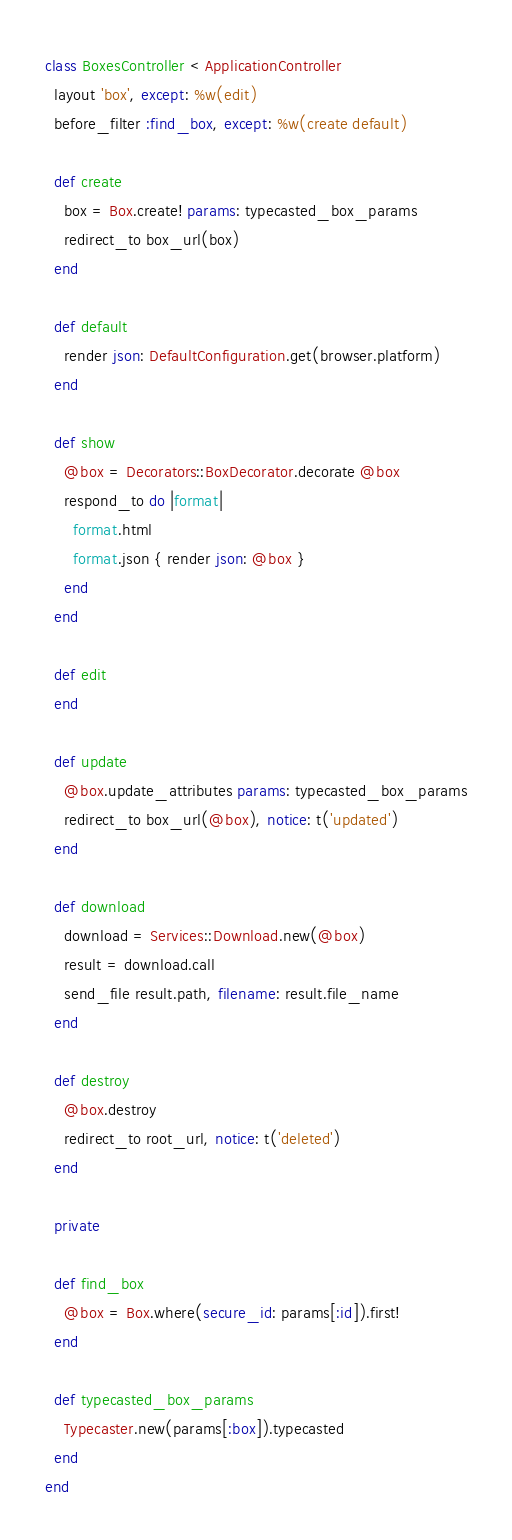<code> <loc_0><loc_0><loc_500><loc_500><_Ruby_>class BoxesController < ApplicationController
  layout 'box', except: %w(edit)
  before_filter :find_box, except: %w(create default)

  def create
    box = Box.create! params: typecasted_box_params
    redirect_to box_url(box)
  end

  def default
    render json: DefaultConfiguration.get(browser.platform)
  end

  def show
    @box = Decorators::BoxDecorator.decorate @box
    respond_to do |format|
      format.html
      format.json { render json: @box }
    end
  end

  def edit
  end

  def update
    @box.update_attributes params: typecasted_box_params
    redirect_to box_url(@box), notice: t('updated')
  end

  def download
    download = Services::Download.new(@box)
    result = download.call
    send_file result.path, filename: result.file_name
  end

  def destroy
    @box.destroy
    redirect_to root_url, notice: t('deleted')
  end

  private

  def find_box
    @box = Box.where(secure_id: params[:id]).first!
  end

  def typecasted_box_params
    Typecaster.new(params[:box]).typecasted
  end
end
</code> 